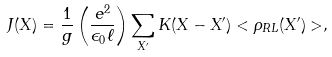Convert formula to latex. <formula><loc_0><loc_0><loc_500><loc_500>J ( X ) = \frac { 1 } { g } \left ( \frac { e ^ { 2 } } { \epsilon _ { 0 } \ell } \right ) \sum _ { X ^ { \prime } } K ( X - X ^ { \prime } ) < \rho _ { R L } ( X ^ { \prime } ) > ,</formula> 